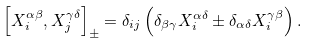Convert formula to latex. <formula><loc_0><loc_0><loc_500><loc_500>\left [ X ^ { \alpha \beta } _ { i } , X ^ { \gamma \delta } _ { j } \right ] _ { \pm } = \delta _ { i j } \left ( \delta _ { \beta \gamma } X ^ { \alpha \delta } _ { i } \pm \delta _ { \alpha \delta } X ^ { \gamma \beta } _ { i } \right ) .</formula> 